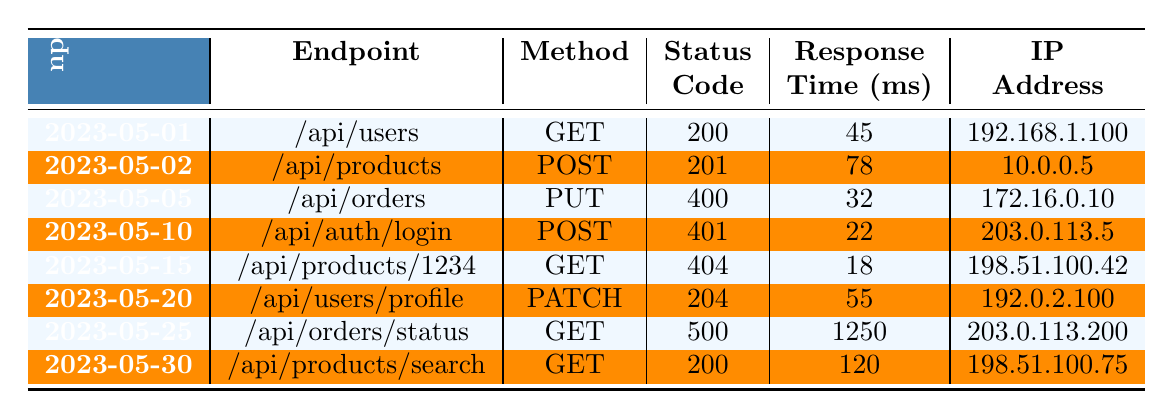What is the status code for the endpoint "/api/orders"? Looking at the table, the row for the endpoint "/api/orders" shows a status code of 400.
Answer: 400 How many different HTTP methods are used in the requests logged? The methods listed in the table are GET, POST, PUT, PATCH, and one instance of each appears; thus, there are 5 unique methods.
Answer: 5 What is the average response time for all the requests? Calculating the average response time: (45 + 78 + 32 + 22 + 18 + 55 + 1250 + 120) = 1570. There are 8 requests, so the average response time is 1570/8 = 196.25 ms.
Answer: 196.25 Was there a successful request (status code 200) on May 02? On May 02, the request to "/api/products" has a status code of 201, which indicates it was successful, but it is not a 200 status code.
Answer: No Which endpoint had the highest response time, and what was that time? The endpoint "/api/orders/status" has the highest response time recorded at 1250 ms.
Answer: /api/orders/status, 1250 ms How many requests resulted in a client error (status codes in the 400 range)? The requests with status codes of 400 and 401 are both client errors, totaling 2 requests (one for each code).
Answer: 2 What percentage of requests returned a successful status code? There are 5 successful requests (status codes 200, 201, 204) out of 8 total requests. The calculation is (5/8) * 100 = 62.5%.
Answer: 62.5% Was there an instance where the status code was 500? Yes, the row for the endpoint "/api/orders/status" indicates a status code of 500.
Answer: Yes Which user agent was used for the request with the highest response time? The request with the highest response time (1250 ms) came from the user agent "Mozilla/5.0 (Windows NT 10.0; Win64; x64; rv:109.0) Gecko/20100101 Firefox/113.0".
Answer: Mozilla/5.0 (Windows NT 10.0; Win64; x64; rv:109.0) Gecko/20100101 Firefox/113.0 What proportion of requests had a status code that indicated an error (either client or server error)? The requests indicating errors include one with status code 400, one with 401, and one with 500, totaling 3 errors out of 8 requests. The proportion is 3/8 = 0.375 or 37.5%.
Answer: 37.5% 